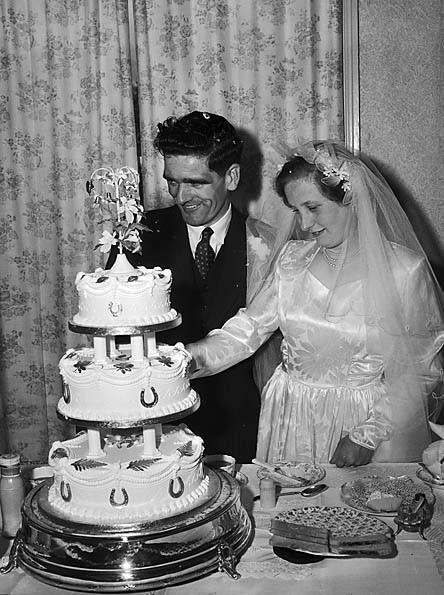How many tiers is this wedding cake?
Give a very brief answer. 3. How many cakes are in the picture?
Give a very brief answer. 3. How many people are there?
Give a very brief answer. 2. How many toothbrushes are in this photo?
Give a very brief answer. 0. 